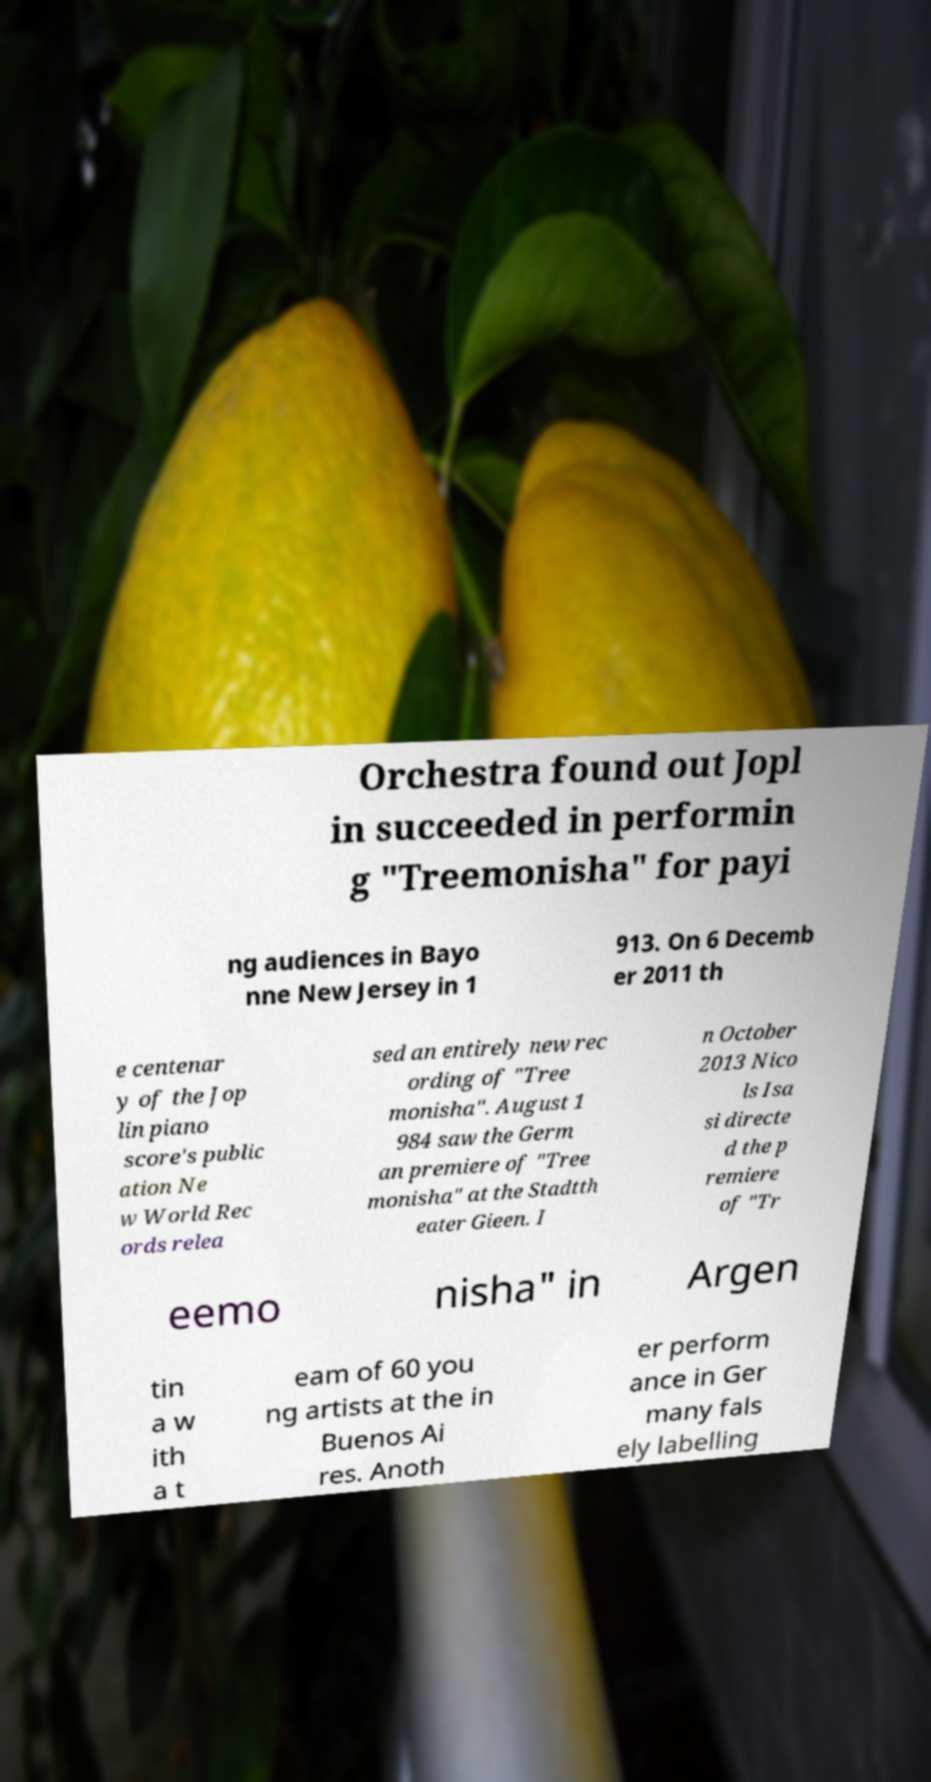Could you extract and type out the text from this image? Orchestra found out Jopl in succeeded in performin g "Treemonisha" for payi ng audiences in Bayo nne New Jersey in 1 913. On 6 Decemb er 2011 th e centenar y of the Jop lin piano score's public ation Ne w World Rec ords relea sed an entirely new rec ording of "Tree monisha". August 1 984 saw the Germ an premiere of "Tree monisha" at the Stadtth eater Gieen. I n October 2013 Nico ls Isa si directe d the p remiere of "Tr eemo nisha" in Argen tin a w ith a t eam of 60 you ng artists at the in Buenos Ai res. Anoth er perform ance in Ger many fals ely labelling 